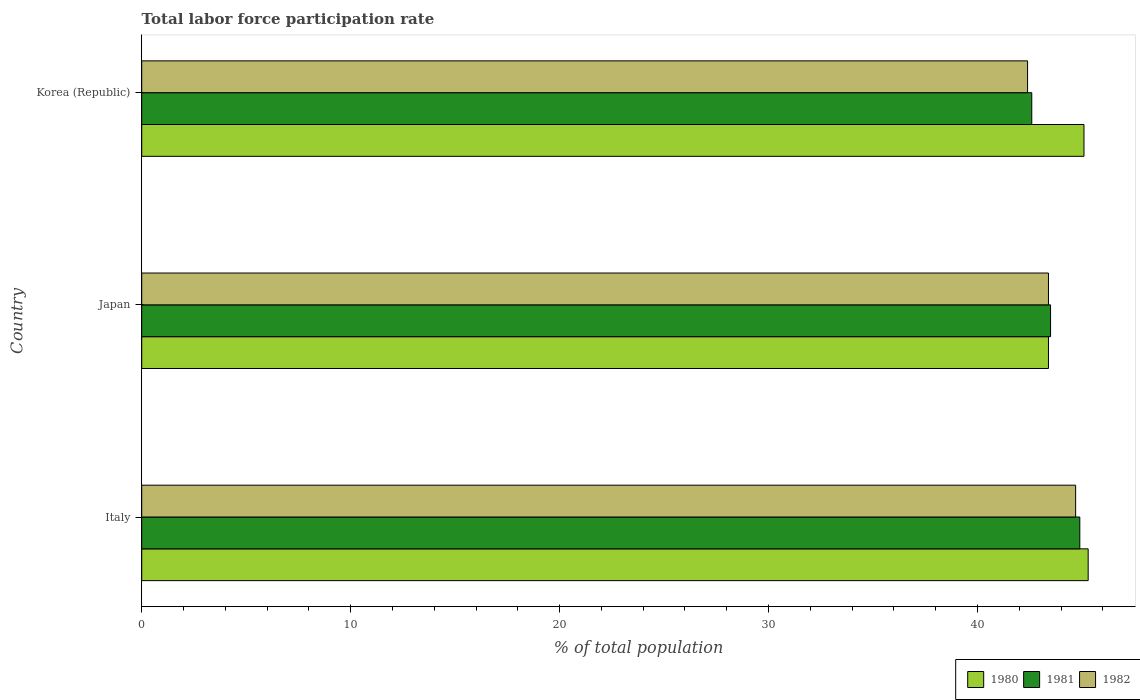How many different coloured bars are there?
Your response must be concise. 3. How many groups of bars are there?
Provide a short and direct response. 3. How many bars are there on the 3rd tick from the top?
Your response must be concise. 3. In how many cases, is the number of bars for a given country not equal to the number of legend labels?
Offer a very short reply. 0. What is the total labor force participation rate in 1982 in Korea (Republic)?
Give a very brief answer. 42.4. Across all countries, what is the maximum total labor force participation rate in 1980?
Provide a succinct answer. 45.3. Across all countries, what is the minimum total labor force participation rate in 1980?
Provide a short and direct response. 43.4. What is the total total labor force participation rate in 1980 in the graph?
Give a very brief answer. 133.8. What is the difference between the total labor force participation rate in 1981 in Italy and that in Korea (Republic)?
Provide a short and direct response. 2.3. What is the difference between the total labor force participation rate in 1980 in Italy and the total labor force participation rate in 1982 in Japan?
Provide a succinct answer. 1.9. What is the average total labor force participation rate in 1980 per country?
Your response must be concise. 44.6. In how many countries, is the total labor force participation rate in 1981 greater than 36 %?
Provide a short and direct response. 3. What is the ratio of the total labor force participation rate in 1981 in Japan to that in Korea (Republic)?
Your answer should be compact. 1.02. Is the difference between the total labor force participation rate in 1981 in Italy and Korea (Republic) greater than the difference between the total labor force participation rate in 1980 in Italy and Korea (Republic)?
Your answer should be very brief. Yes. What is the difference between the highest and the second highest total labor force participation rate in 1982?
Ensure brevity in your answer.  1.3. What is the difference between the highest and the lowest total labor force participation rate in 1982?
Your response must be concise. 2.3. Is it the case that in every country, the sum of the total labor force participation rate in 1982 and total labor force participation rate in 1981 is greater than the total labor force participation rate in 1980?
Offer a terse response. Yes. How many bars are there?
Make the answer very short. 9. How many countries are there in the graph?
Ensure brevity in your answer.  3. Does the graph contain grids?
Your answer should be compact. No. Where does the legend appear in the graph?
Your response must be concise. Bottom right. How many legend labels are there?
Offer a very short reply. 3. What is the title of the graph?
Ensure brevity in your answer.  Total labor force participation rate. Does "1982" appear as one of the legend labels in the graph?
Provide a short and direct response. Yes. What is the label or title of the X-axis?
Your answer should be compact. % of total population. What is the % of total population of 1980 in Italy?
Offer a terse response. 45.3. What is the % of total population of 1981 in Italy?
Provide a short and direct response. 44.9. What is the % of total population of 1982 in Italy?
Provide a short and direct response. 44.7. What is the % of total population of 1980 in Japan?
Provide a succinct answer. 43.4. What is the % of total population in 1981 in Japan?
Offer a terse response. 43.5. What is the % of total population in 1982 in Japan?
Offer a very short reply. 43.4. What is the % of total population of 1980 in Korea (Republic)?
Offer a very short reply. 45.1. What is the % of total population of 1981 in Korea (Republic)?
Offer a terse response. 42.6. What is the % of total population in 1982 in Korea (Republic)?
Keep it short and to the point. 42.4. Across all countries, what is the maximum % of total population of 1980?
Provide a short and direct response. 45.3. Across all countries, what is the maximum % of total population in 1981?
Provide a succinct answer. 44.9. Across all countries, what is the maximum % of total population in 1982?
Keep it short and to the point. 44.7. Across all countries, what is the minimum % of total population of 1980?
Your answer should be compact. 43.4. Across all countries, what is the minimum % of total population of 1981?
Your answer should be very brief. 42.6. Across all countries, what is the minimum % of total population of 1982?
Ensure brevity in your answer.  42.4. What is the total % of total population in 1980 in the graph?
Provide a short and direct response. 133.8. What is the total % of total population of 1981 in the graph?
Ensure brevity in your answer.  131. What is the total % of total population in 1982 in the graph?
Ensure brevity in your answer.  130.5. What is the difference between the % of total population of 1980 in Italy and that in Korea (Republic)?
Your answer should be very brief. 0.2. What is the difference between the % of total population in 1981 in Italy and that in Korea (Republic)?
Provide a succinct answer. 2.3. What is the difference between the % of total population of 1981 in Japan and that in Korea (Republic)?
Keep it short and to the point. 0.9. What is the difference between the % of total population of 1982 in Japan and that in Korea (Republic)?
Make the answer very short. 1. What is the difference between the % of total population in 1981 in Italy and the % of total population in 1982 in Japan?
Your answer should be very brief. 1.5. What is the difference between the % of total population of 1980 in Italy and the % of total population of 1981 in Korea (Republic)?
Your answer should be compact. 2.7. What is the difference between the % of total population of 1981 in Italy and the % of total population of 1982 in Korea (Republic)?
Offer a terse response. 2.5. What is the difference between the % of total population of 1980 in Japan and the % of total population of 1981 in Korea (Republic)?
Make the answer very short. 0.8. What is the average % of total population in 1980 per country?
Your answer should be compact. 44.6. What is the average % of total population of 1981 per country?
Make the answer very short. 43.67. What is the average % of total population of 1982 per country?
Give a very brief answer. 43.5. What is the difference between the % of total population of 1980 and % of total population of 1982 in Italy?
Keep it short and to the point. 0.6. What is the difference between the % of total population of 1981 and % of total population of 1982 in Italy?
Ensure brevity in your answer.  0.2. What is the difference between the % of total population of 1980 and % of total population of 1981 in Japan?
Your answer should be very brief. -0.1. What is the difference between the % of total population of 1980 and % of total population of 1982 in Korea (Republic)?
Offer a terse response. 2.7. What is the difference between the % of total population in 1981 and % of total population in 1982 in Korea (Republic)?
Your answer should be very brief. 0.2. What is the ratio of the % of total population of 1980 in Italy to that in Japan?
Provide a succinct answer. 1.04. What is the ratio of the % of total population of 1981 in Italy to that in Japan?
Provide a short and direct response. 1.03. What is the ratio of the % of total population in 1980 in Italy to that in Korea (Republic)?
Give a very brief answer. 1. What is the ratio of the % of total population in 1981 in Italy to that in Korea (Republic)?
Give a very brief answer. 1.05. What is the ratio of the % of total population in 1982 in Italy to that in Korea (Republic)?
Ensure brevity in your answer.  1.05. What is the ratio of the % of total population of 1980 in Japan to that in Korea (Republic)?
Provide a succinct answer. 0.96. What is the ratio of the % of total population of 1981 in Japan to that in Korea (Republic)?
Provide a short and direct response. 1.02. What is the ratio of the % of total population of 1982 in Japan to that in Korea (Republic)?
Keep it short and to the point. 1.02. What is the difference between the highest and the second highest % of total population in 1980?
Make the answer very short. 0.2. 